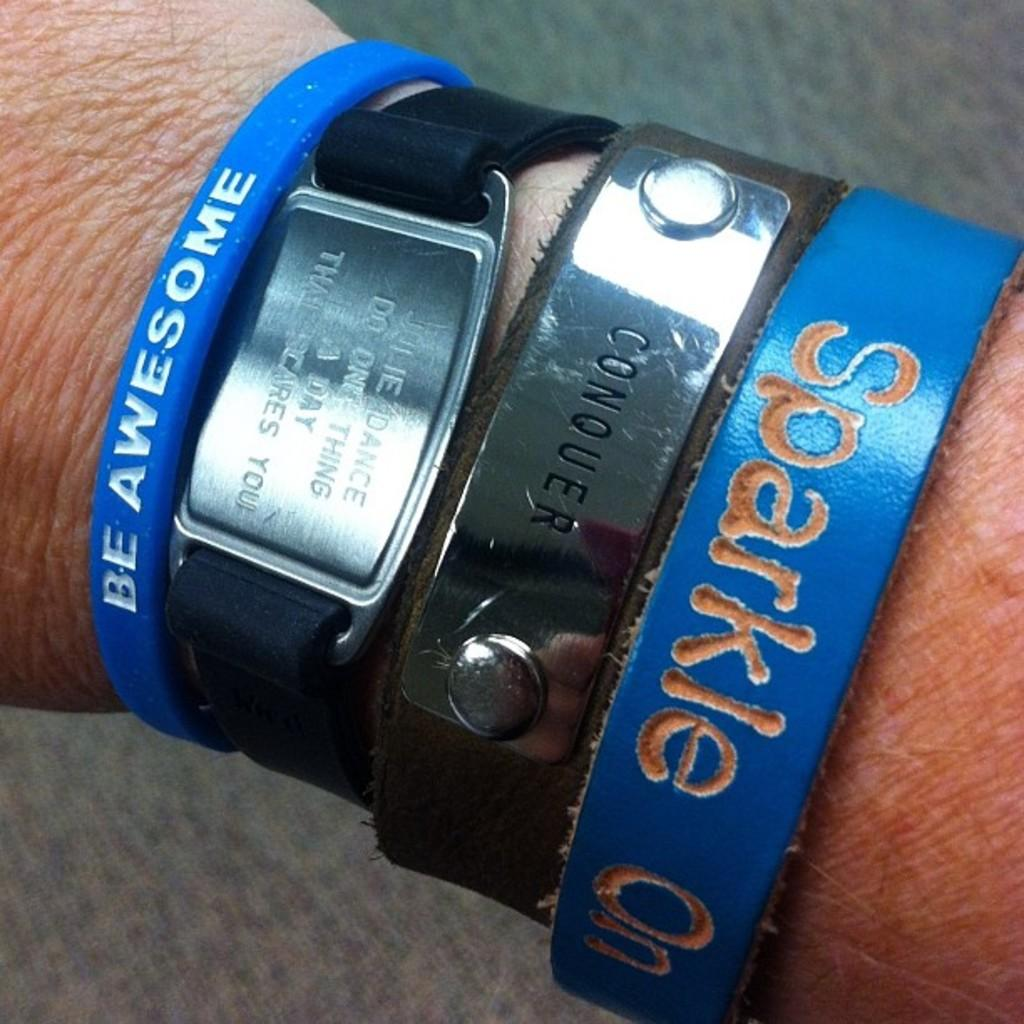What part of a person's body is visible in the image? There is a person's hand in the image. What is on the hand in the image? The hand has a watch and bracelets on it. What can be seen in the background of the image? There is a platform visible in the background of the image. What grade did the person receive for their performance in the image? There is no indication of a performance or grade in the image; it only shows a person's hand with a watch and bracelets. How many boots are visible in the image? There are no boots present in the image. 